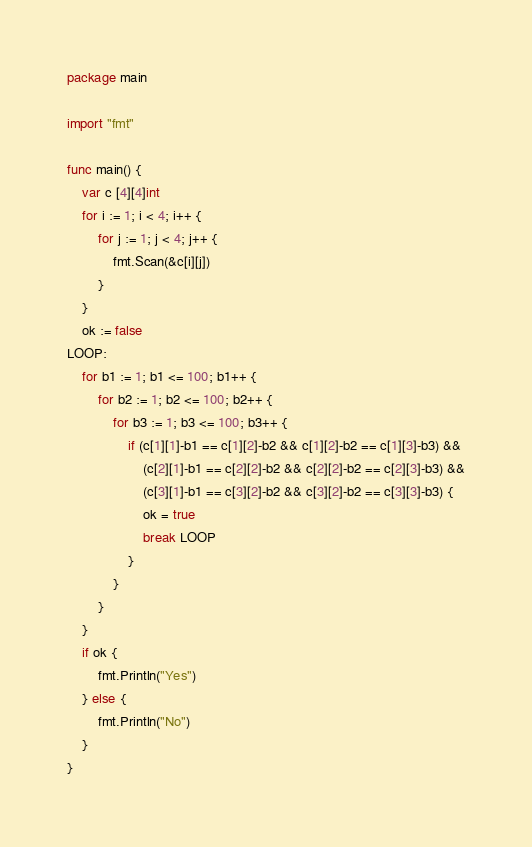<code> <loc_0><loc_0><loc_500><loc_500><_Go_>package main

import "fmt"

func main() {
	var c [4][4]int
	for i := 1; i < 4; i++ {
		for j := 1; j < 4; j++ {
			fmt.Scan(&c[i][j])
		}
	}
	ok := false
LOOP:
	for b1 := 1; b1 <= 100; b1++ {
		for b2 := 1; b2 <= 100; b2++ {
			for b3 := 1; b3 <= 100; b3++ {
				if (c[1][1]-b1 == c[1][2]-b2 && c[1][2]-b2 == c[1][3]-b3) &&
					(c[2][1]-b1 == c[2][2]-b2 && c[2][2]-b2 == c[2][3]-b3) &&
					(c[3][1]-b1 == c[3][2]-b2 && c[3][2]-b2 == c[3][3]-b3) {
					ok = true
					break LOOP
				}
			}
		}
	}
	if ok {
		fmt.Println("Yes")
	} else {
		fmt.Println("No")
	}
}
</code> 